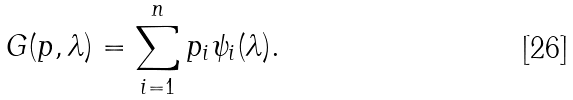Convert formula to latex. <formula><loc_0><loc_0><loc_500><loc_500>G ( p , \lambda ) = \sum _ { i = 1 } ^ { n } p _ { i } \psi _ { i } ( \lambda ) .</formula> 